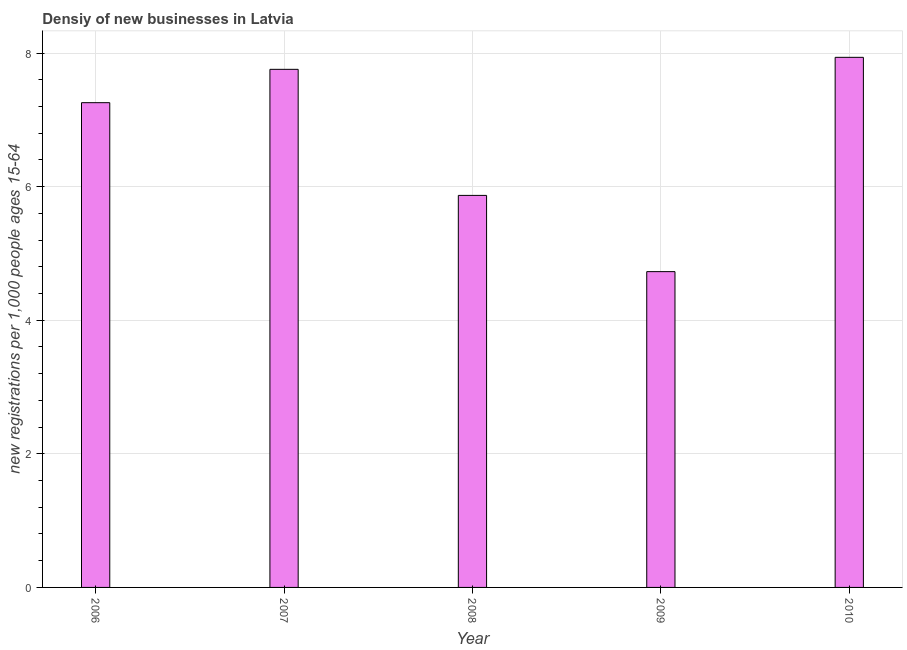What is the title of the graph?
Give a very brief answer. Densiy of new businesses in Latvia. What is the label or title of the Y-axis?
Your answer should be very brief. New registrations per 1,0 people ages 15-64. What is the density of new business in 2006?
Offer a very short reply. 7.26. Across all years, what is the maximum density of new business?
Make the answer very short. 7.94. Across all years, what is the minimum density of new business?
Give a very brief answer. 4.73. In which year was the density of new business maximum?
Your answer should be compact. 2010. In which year was the density of new business minimum?
Offer a terse response. 2009. What is the sum of the density of new business?
Make the answer very short. 33.55. What is the difference between the density of new business in 2006 and 2009?
Give a very brief answer. 2.53. What is the average density of new business per year?
Offer a terse response. 6.71. What is the median density of new business?
Make the answer very short. 7.26. What is the ratio of the density of new business in 2006 to that in 2009?
Your answer should be very brief. 1.53. Is the density of new business in 2008 less than that in 2009?
Your answer should be very brief. No. What is the difference between the highest and the second highest density of new business?
Make the answer very short. 0.18. Is the sum of the density of new business in 2006 and 2009 greater than the maximum density of new business across all years?
Offer a terse response. Yes. What is the difference between the highest and the lowest density of new business?
Keep it short and to the point. 3.21. How many bars are there?
Offer a terse response. 5. How many years are there in the graph?
Ensure brevity in your answer.  5. Are the values on the major ticks of Y-axis written in scientific E-notation?
Offer a very short reply. No. What is the new registrations per 1,000 people ages 15-64 in 2006?
Your answer should be compact. 7.26. What is the new registrations per 1,000 people ages 15-64 of 2007?
Ensure brevity in your answer.  7.76. What is the new registrations per 1,000 people ages 15-64 of 2008?
Offer a terse response. 5.87. What is the new registrations per 1,000 people ages 15-64 in 2009?
Give a very brief answer. 4.73. What is the new registrations per 1,000 people ages 15-64 in 2010?
Provide a short and direct response. 7.94. What is the difference between the new registrations per 1,000 people ages 15-64 in 2006 and 2007?
Offer a very short reply. -0.5. What is the difference between the new registrations per 1,000 people ages 15-64 in 2006 and 2008?
Your answer should be compact. 1.39. What is the difference between the new registrations per 1,000 people ages 15-64 in 2006 and 2009?
Provide a succinct answer. 2.53. What is the difference between the new registrations per 1,000 people ages 15-64 in 2006 and 2010?
Provide a succinct answer. -0.68. What is the difference between the new registrations per 1,000 people ages 15-64 in 2007 and 2008?
Offer a very short reply. 1.89. What is the difference between the new registrations per 1,000 people ages 15-64 in 2007 and 2009?
Provide a short and direct response. 3.03. What is the difference between the new registrations per 1,000 people ages 15-64 in 2007 and 2010?
Provide a short and direct response. -0.18. What is the difference between the new registrations per 1,000 people ages 15-64 in 2008 and 2009?
Your answer should be compact. 1.14. What is the difference between the new registrations per 1,000 people ages 15-64 in 2008 and 2010?
Offer a terse response. -2.07. What is the difference between the new registrations per 1,000 people ages 15-64 in 2009 and 2010?
Ensure brevity in your answer.  -3.21. What is the ratio of the new registrations per 1,000 people ages 15-64 in 2006 to that in 2007?
Ensure brevity in your answer.  0.94. What is the ratio of the new registrations per 1,000 people ages 15-64 in 2006 to that in 2008?
Offer a very short reply. 1.24. What is the ratio of the new registrations per 1,000 people ages 15-64 in 2006 to that in 2009?
Give a very brief answer. 1.53. What is the ratio of the new registrations per 1,000 people ages 15-64 in 2006 to that in 2010?
Offer a terse response. 0.91. What is the ratio of the new registrations per 1,000 people ages 15-64 in 2007 to that in 2008?
Keep it short and to the point. 1.32. What is the ratio of the new registrations per 1,000 people ages 15-64 in 2007 to that in 2009?
Your response must be concise. 1.64. What is the ratio of the new registrations per 1,000 people ages 15-64 in 2007 to that in 2010?
Make the answer very short. 0.98. What is the ratio of the new registrations per 1,000 people ages 15-64 in 2008 to that in 2009?
Offer a very short reply. 1.24. What is the ratio of the new registrations per 1,000 people ages 15-64 in 2008 to that in 2010?
Provide a short and direct response. 0.74. What is the ratio of the new registrations per 1,000 people ages 15-64 in 2009 to that in 2010?
Offer a terse response. 0.6. 